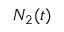<formula> <loc_0><loc_0><loc_500><loc_500>N _ { 2 } ( t )</formula> 